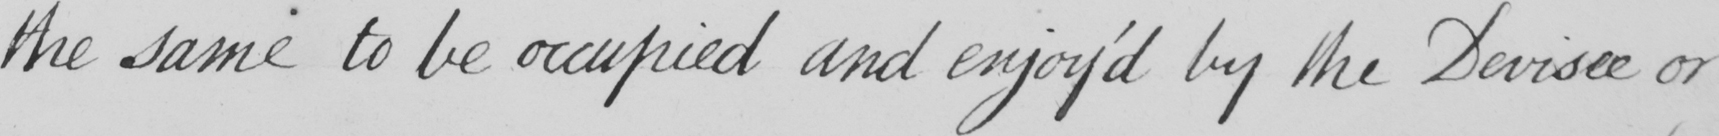Transcribe the text shown in this historical manuscript line. the same to be occupied and enjoy ' d by the Devisee or 